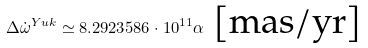<formula> <loc_0><loc_0><loc_500><loc_500>\Delta \dot { \omega } ^ { Y u k } \simeq 8 . 2 9 2 3 5 8 6 \cdot 1 0 ^ { 1 1 } \alpha \ \text {[mas/yr]}</formula> 